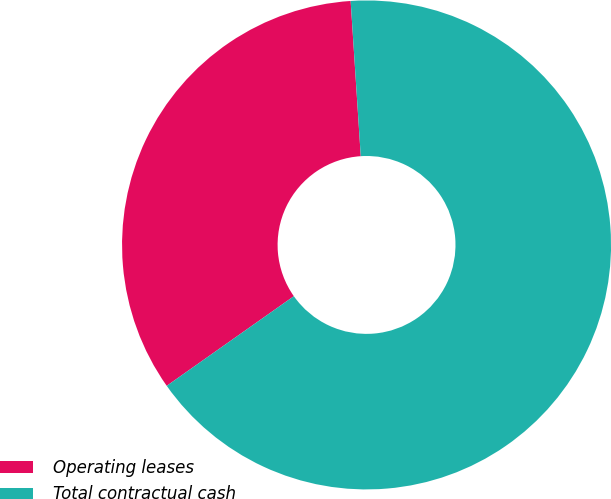Convert chart. <chart><loc_0><loc_0><loc_500><loc_500><pie_chart><fcel>Operating leases<fcel>Total contractual cash<nl><fcel>33.74%<fcel>66.26%<nl></chart> 